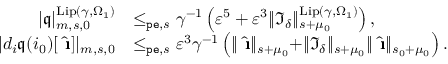Convert formula to latex. <formula><loc_0><loc_0><loc_500><loc_500>\begin{array} { r l } { | \mathfrak { q } | _ { m , s , 0 } ^ { L i p ( \gamma , \Omega _ { 1 } ) } } & { \leq _ { p e , s } \gamma ^ { - 1 } \left ( \varepsilon ^ { 5 } + \varepsilon ^ { 3 } \| \mathfrak { I } _ { \delta } \| _ { s + \mu _ { 0 } } ^ { L i p ( \gamma , \Omega _ { 1 } ) } \right ) , } \\ { | d _ { i } \mathfrak { q } ( i _ { 0 } ) [ \hat { \i } ] | _ { m , s , 0 } } & { \leq _ { p e , s } \varepsilon ^ { 3 } \gamma ^ { - 1 } \left ( \| \hat { \i } \| _ { s + \mu _ { 0 } } + \| \mathfrak { I } _ { \delta } \| _ { s + \mu _ { 0 } } \| \hat { \i } \| _ { s _ { 0 } + \mu _ { 0 } } \right ) . } \end{array}</formula> 